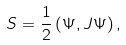Convert formula to latex. <formula><loc_0><loc_0><loc_500><loc_500>S = \frac { 1 } { 2 } \left ( \Psi , J \Psi \right ) ,</formula> 